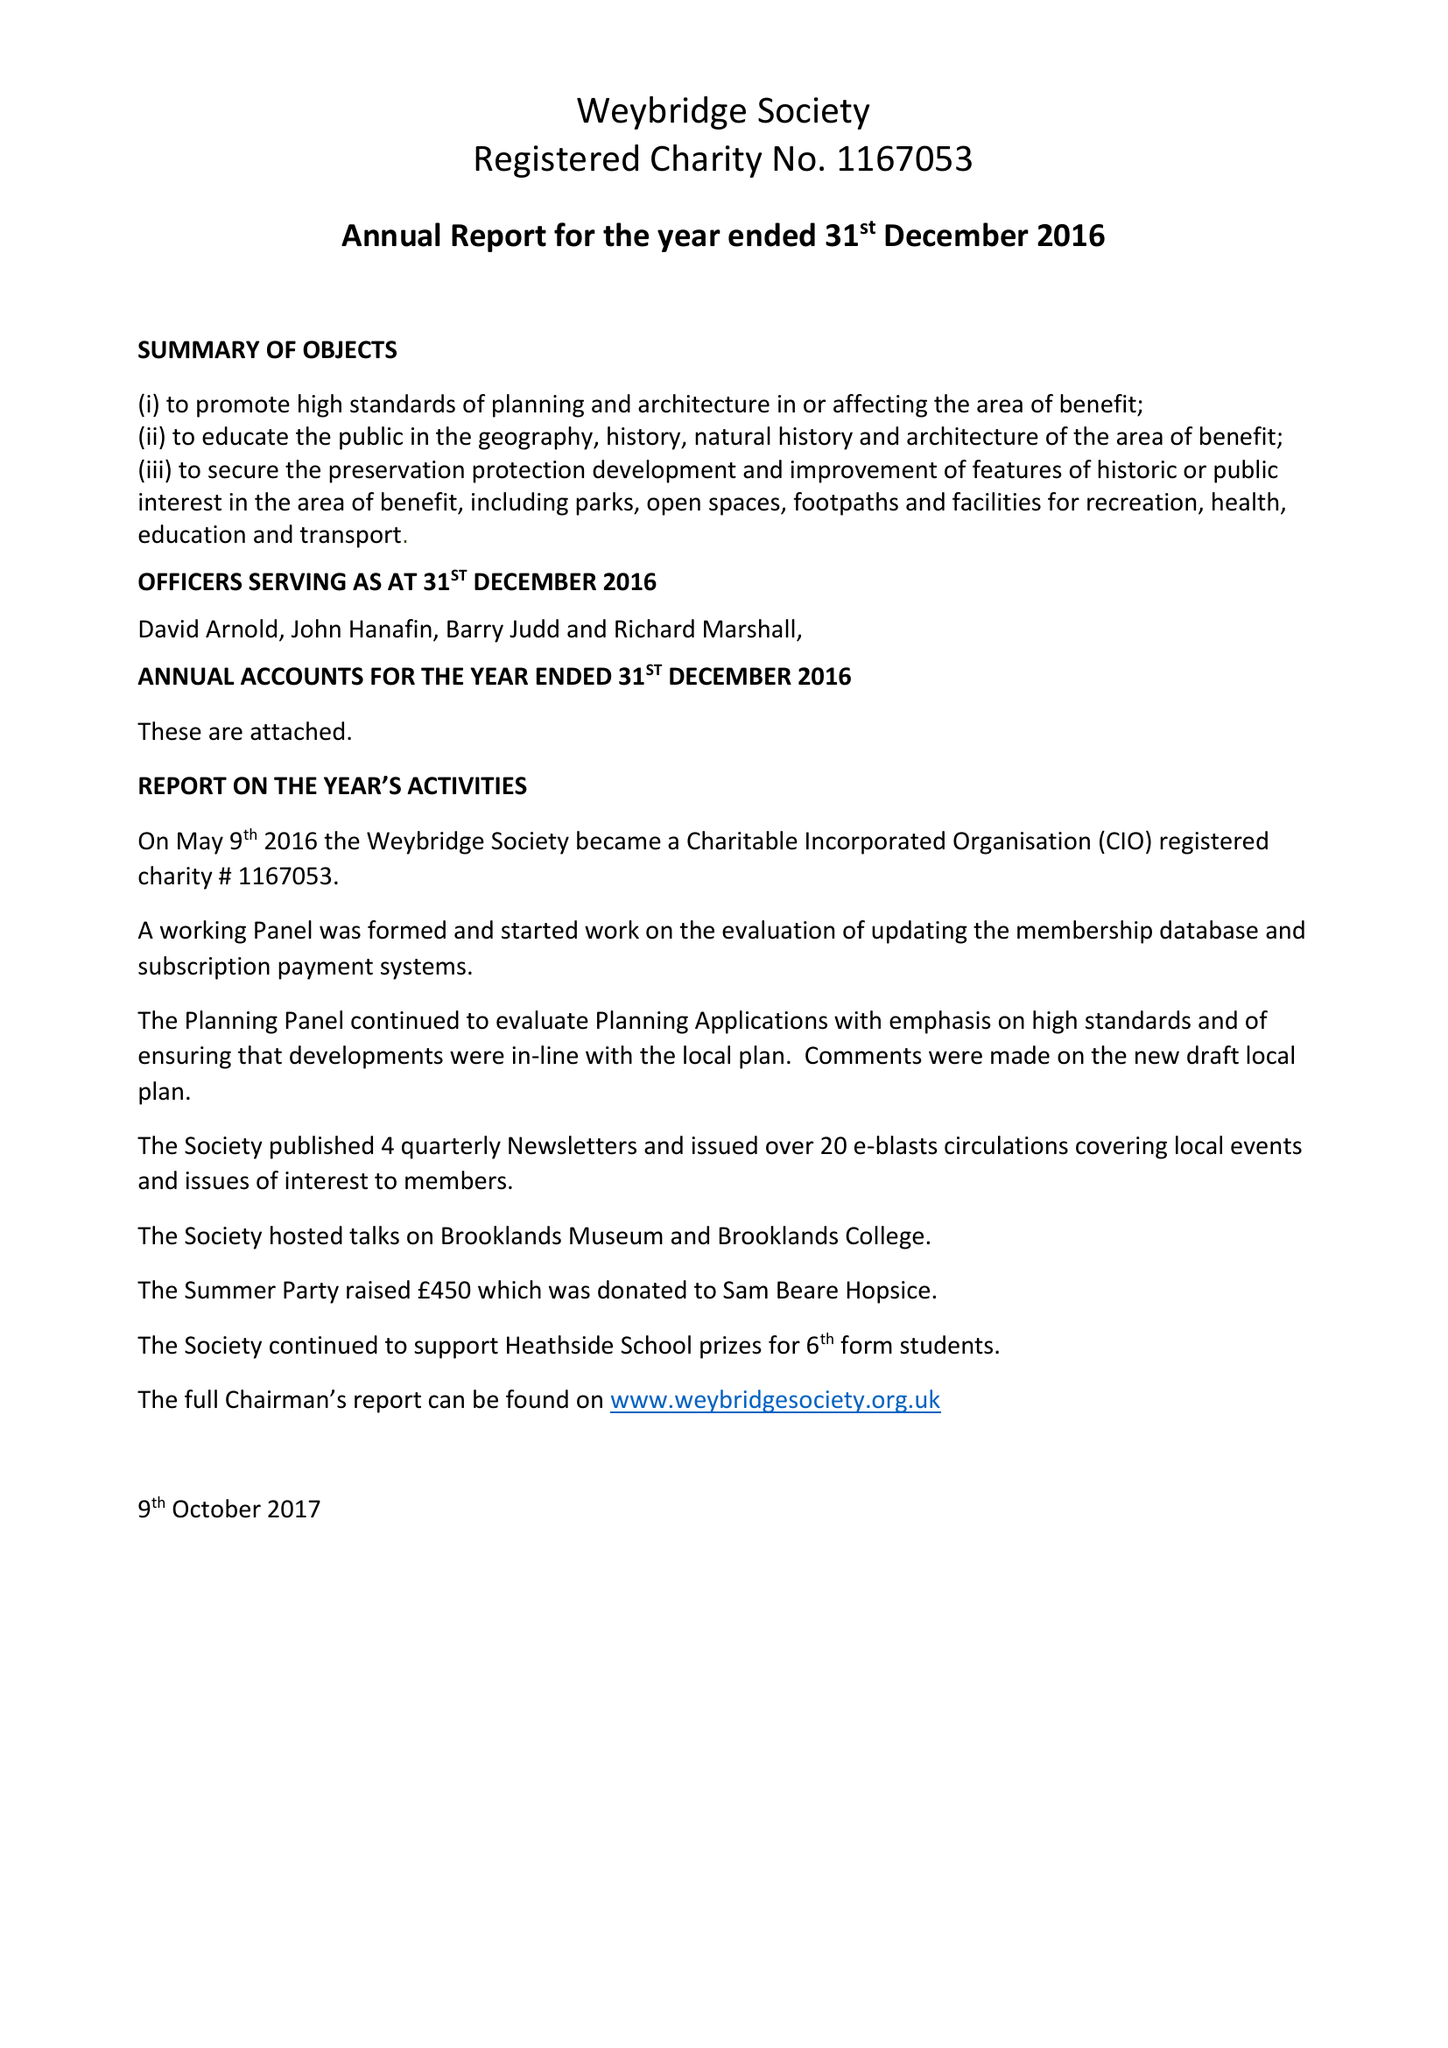What is the value for the report_date?
Answer the question using a single word or phrase. 2016-12-31 